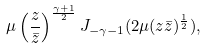Convert formula to latex. <formula><loc_0><loc_0><loc_500><loc_500>\mu \left ( \frac { z } { \bar { z } } \right ) ^ { \frac { \gamma + 1 } { 2 } } J _ { - \gamma - 1 } ( 2 \mu ( z \bar { z } ) ^ { \frac { 1 } { 2 } } ) ,</formula> 